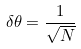<formula> <loc_0><loc_0><loc_500><loc_500>\delta \theta = \frac { 1 } { \sqrt { N } }</formula> 